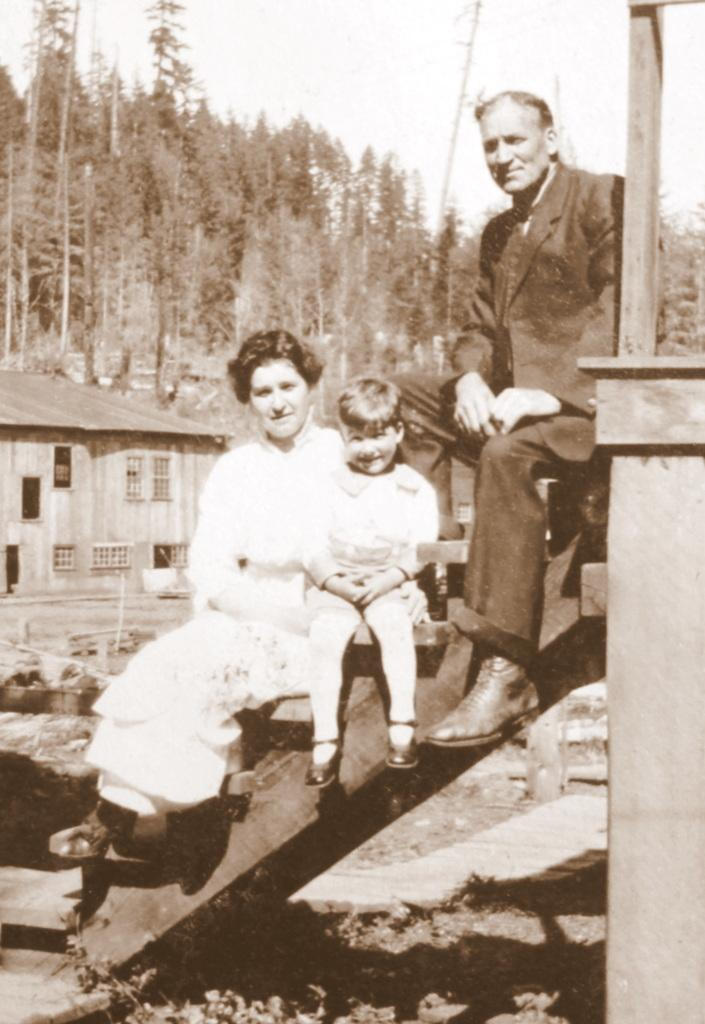What is the color scheme of the image? The image is black and white. How many people are in the image? There is a man, a boy, and a woman in the image. What are the people doing in the image? The people are sitting on stairs. What type of structure is visible in the image? There is a house in the image. What features can be seen on the house? The house has windows. What other elements are present in the image? There are trees in the image. Can you describe the smell of the lake in the image? There is no lake present in the image, so it is not possible to describe its smell. 